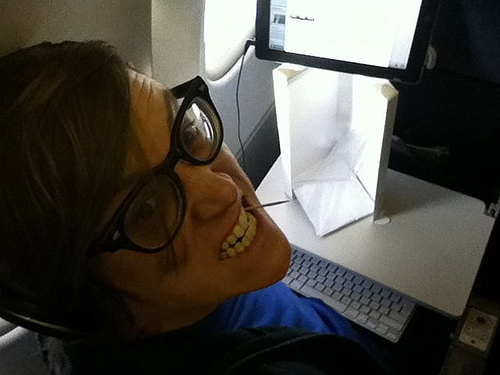Is the telephone in the top part or in the bottom of the photo? The telephone is located in the bottom part of the photo. 